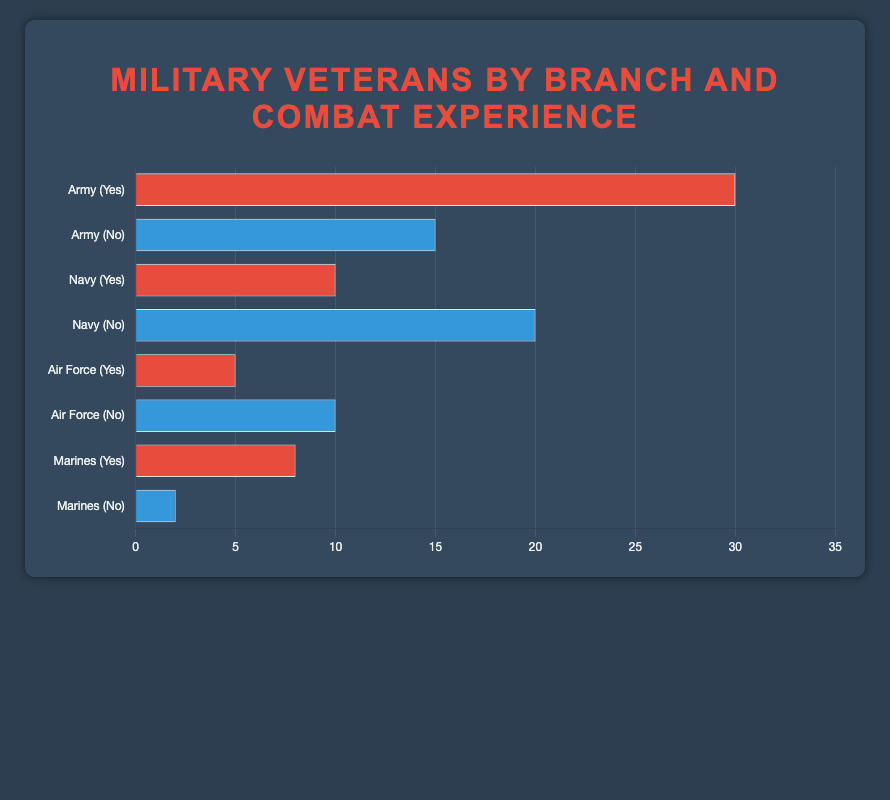What percentage of veterans from the Army have combat experience? The figure shows a horizontal bar for the Army labeled "Yes" indicating combat experience. We can see this bar represents 30%.
Answer: 30% How many percentage points more veterans in the Army have combat experience compared to those who do not? To find the difference, subtract the percentage of Army veterans without combat experience (15%) from those with combat experience (30%). So, 30 - 15 = 15 percentage points.
Answer: 15 Which branch has a larger percentage of veterans with combat experience, Navy or Marines? By comparing the bars labeled "Yes" for both branches, the Navy shows 10% while the Marines show 8%. Thus, the Navy has a larger percentage of veterans with combat experience.
Answer: Navy What is the total percentage of veterans in the Air Force? Add the percentage of veterans in the Air Force with combat experience (5%) to those without combat experience (10%). So, 5 + 10 = 15%.
Answer: 15% What percentage of veterans do not have combat experience in the Marines? The figure shows a horizontal bar for the Marines labeled "No" indicating non-combat experience. This bar represents 2%.
Answer: 2% Which branch has the highest percentage of veterans without combat experience? By comparing the bars labeled "No" for each branch, we see that the Navy has the highest percentage at 20%.
Answer: Navy How much greater is the percentage of veterans with combat experience in the Army compared to the Air Force? Subtract the percentage of Air Force veterans with combat experience (5%) from Army veterans with combat experience (30%). So, 30 - 5 = 25 percentage points greater.
Answer: 25 Which branch has equal percentages of veterans with and without combat experience? By observing the figure, we see that the Air Force shows equal percentages for both combat and non-combat experience, each with 10%.
Answer: Air Force 